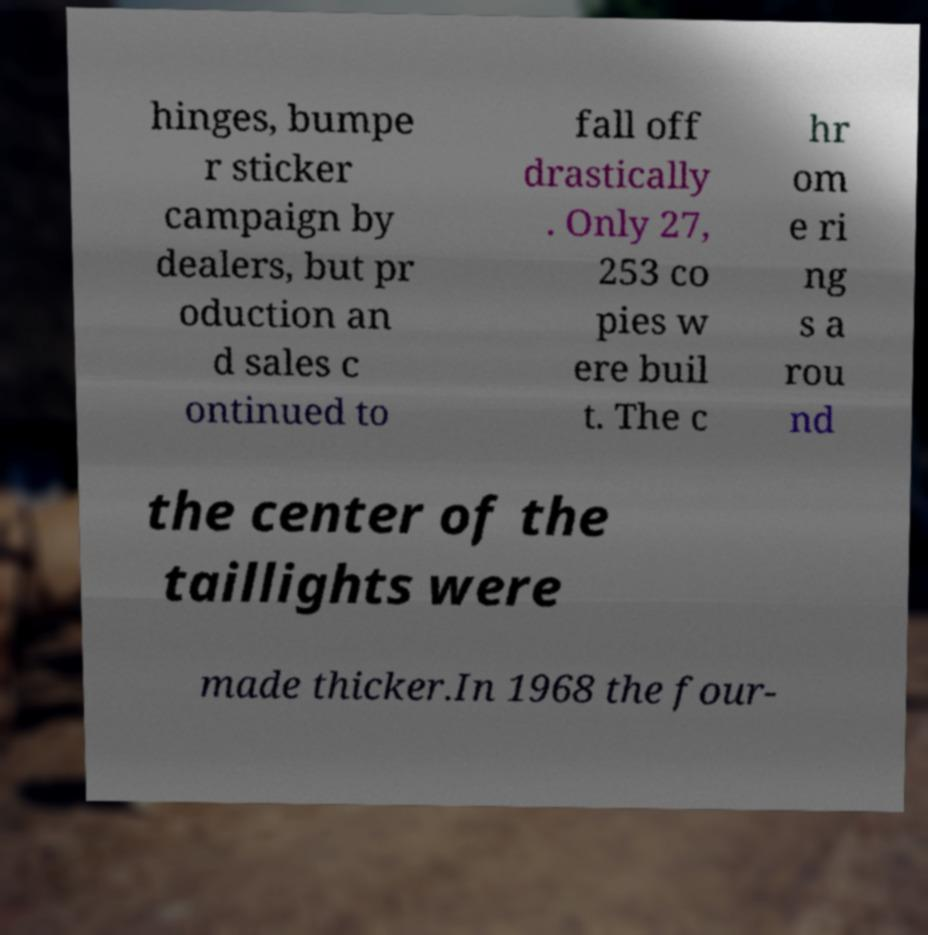Please identify and transcribe the text found in this image. hinges, bumpe r sticker campaign by dealers, but pr oduction an d sales c ontinued to fall off drastically . Only 27, 253 co pies w ere buil t. The c hr om e ri ng s a rou nd the center of the taillights were made thicker.In 1968 the four- 